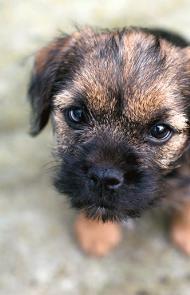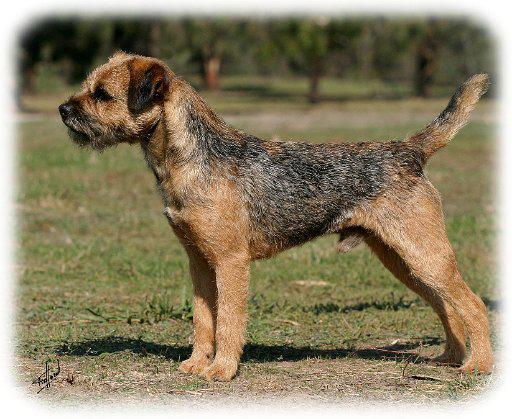The first image is the image on the left, the second image is the image on the right. Analyze the images presented: Is the assertion "One of the dogs is a puppy, and the other is in his middle years; you can visually verify their ages easily." valid? Answer yes or no. Yes. The first image is the image on the left, the second image is the image on the right. Analyze the images presented: Is the assertion "Every image shows exactly one dog, and in images where the dog is standing outside in grass the dog is facing the left." valid? Answer yes or no. Yes. 